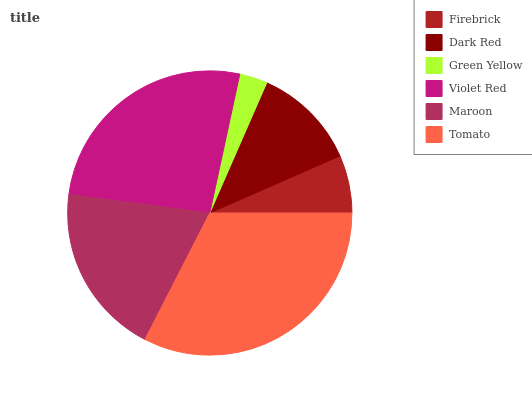Is Green Yellow the minimum?
Answer yes or no. Yes. Is Tomato the maximum?
Answer yes or no. Yes. Is Dark Red the minimum?
Answer yes or no. No. Is Dark Red the maximum?
Answer yes or no. No. Is Dark Red greater than Firebrick?
Answer yes or no. Yes. Is Firebrick less than Dark Red?
Answer yes or no. Yes. Is Firebrick greater than Dark Red?
Answer yes or no. No. Is Dark Red less than Firebrick?
Answer yes or no. No. Is Maroon the high median?
Answer yes or no. Yes. Is Dark Red the low median?
Answer yes or no. Yes. Is Violet Red the high median?
Answer yes or no. No. Is Tomato the low median?
Answer yes or no. No. 